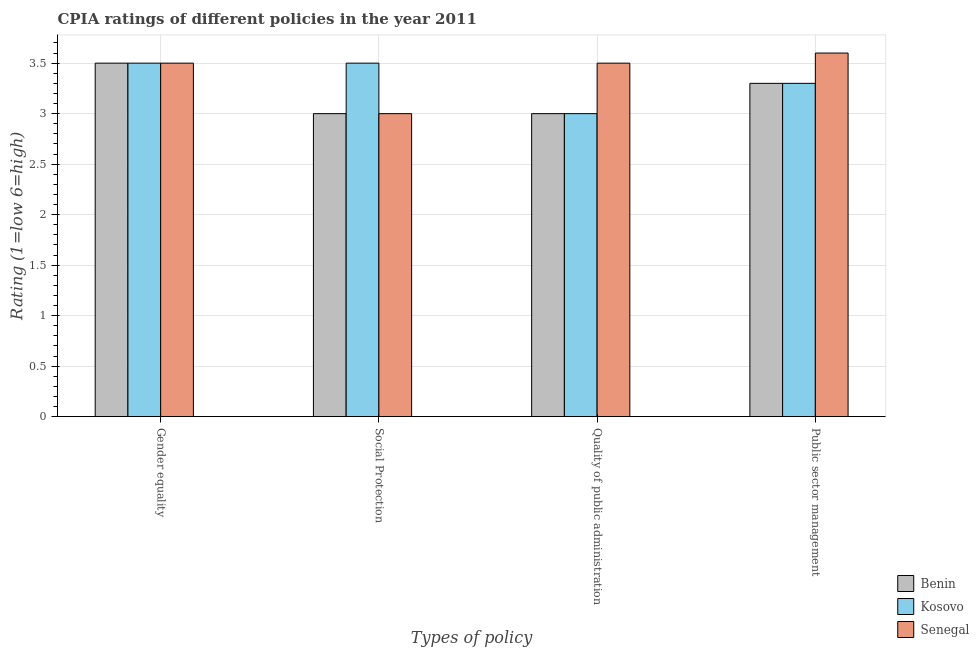Are the number of bars per tick equal to the number of legend labels?
Provide a short and direct response. Yes. How many bars are there on the 3rd tick from the left?
Provide a succinct answer. 3. What is the label of the 1st group of bars from the left?
Provide a short and direct response. Gender equality. In which country was the cpia rating of gender equality maximum?
Give a very brief answer. Benin. In which country was the cpia rating of quality of public administration minimum?
Offer a terse response. Benin. What is the difference between the cpia rating of public sector management in Senegal and that in Kosovo?
Provide a short and direct response. 0.3. What is the difference between the cpia rating of public sector management in Senegal and the cpia rating of social protection in Kosovo?
Keep it short and to the point. 0.1. What is the average cpia rating of public sector management per country?
Ensure brevity in your answer.  3.4. What is the difference between the cpia rating of public sector management and cpia rating of quality of public administration in Kosovo?
Provide a succinct answer. 0.3. Is the difference between the cpia rating of gender equality in Kosovo and Senegal greater than the difference between the cpia rating of social protection in Kosovo and Senegal?
Keep it short and to the point. No. What is the difference between the highest and the second highest cpia rating of quality of public administration?
Offer a very short reply. 0.5. What is the difference between the highest and the lowest cpia rating of public sector management?
Your answer should be compact. 0.3. Is it the case that in every country, the sum of the cpia rating of social protection and cpia rating of quality of public administration is greater than the sum of cpia rating of public sector management and cpia rating of gender equality?
Ensure brevity in your answer.  No. What does the 3rd bar from the left in Public sector management represents?
Provide a succinct answer. Senegal. What does the 2nd bar from the right in Public sector management represents?
Your response must be concise. Kosovo. Are all the bars in the graph horizontal?
Provide a succinct answer. No. How many countries are there in the graph?
Offer a very short reply. 3. What is the difference between two consecutive major ticks on the Y-axis?
Keep it short and to the point. 0.5. Does the graph contain any zero values?
Offer a terse response. No. Does the graph contain grids?
Your answer should be compact. Yes. Where does the legend appear in the graph?
Your response must be concise. Bottom right. How many legend labels are there?
Your response must be concise. 3. How are the legend labels stacked?
Make the answer very short. Vertical. What is the title of the graph?
Your answer should be very brief. CPIA ratings of different policies in the year 2011. What is the label or title of the X-axis?
Ensure brevity in your answer.  Types of policy. What is the Rating (1=low 6=high) of Senegal in Gender equality?
Offer a terse response. 3.5. What is the Rating (1=low 6=high) in Benin in Social Protection?
Keep it short and to the point. 3. What is the Rating (1=low 6=high) of Benin in Quality of public administration?
Offer a terse response. 3. What is the Rating (1=low 6=high) of Senegal in Quality of public administration?
Give a very brief answer. 3.5. What is the Rating (1=low 6=high) in Benin in Public sector management?
Your answer should be compact. 3.3. What is the Rating (1=low 6=high) of Kosovo in Public sector management?
Keep it short and to the point. 3.3. Across all Types of policy, what is the minimum Rating (1=low 6=high) in Kosovo?
Ensure brevity in your answer.  3. Across all Types of policy, what is the minimum Rating (1=low 6=high) in Senegal?
Keep it short and to the point. 3. What is the total Rating (1=low 6=high) of Benin in the graph?
Offer a very short reply. 12.8. What is the total Rating (1=low 6=high) of Kosovo in the graph?
Ensure brevity in your answer.  13.3. What is the total Rating (1=low 6=high) in Senegal in the graph?
Give a very brief answer. 13.6. What is the difference between the Rating (1=low 6=high) in Benin in Gender equality and that in Social Protection?
Provide a succinct answer. 0.5. What is the difference between the Rating (1=low 6=high) of Senegal in Gender equality and that in Social Protection?
Offer a terse response. 0.5. What is the difference between the Rating (1=low 6=high) of Benin in Gender equality and that in Quality of public administration?
Make the answer very short. 0.5. What is the difference between the Rating (1=low 6=high) of Kosovo in Gender equality and that in Quality of public administration?
Your answer should be very brief. 0.5. What is the difference between the Rating (1=low 6=high) in Benin in Gender equality and that in Public sector management?
Offer a terse response. 0.2. What is the difference between the Rating (1=low 6=high) in Kosovo in Gender equality and that in Public sector management?
Make the answer very short. 0.2. What is the difference between the Rating (1=low 6=high) of Senegal in Gender equality and that in Public sector management?
Ensure brevity in your answer.  -0.1. What is the difference between the Rating (1=low 6=high) in Benin in Social Protection and that in Public sector management?
Make the answer very short. -0.3. What is the difference between the Rating (1=low 6=high) of Senegal in Social Protection and that in Public sector management?
Offer a very short reply. -0.6. What is the difference between the Rating (1=low 6=high) of Benin in Quality of public administration and that in Public sector management?
Your answer should be compact. -0.3. What is the difference between the Rating (1=low 6=high) in Senegal in Quality of public administration and that in Public sector management?
Make the answer very short. -0.1. What is the difference between the Rating (1=low 6=high) of Kosovo in Gender equality and the Rating (1=low 6=high) of Senegal in Social Protection?
Your answer should be compact. 0.5. What is the difference between the Rating (1=low 6=high) in Benin in Gender equality and the Rating (1=low 6=high) in Kosovo in Quality of public administration?
Make the answer very short. 0.5. What is the difference between the Rating (1=low 6=high) in Benin in Gender equality and the Rating (1=low 6=high) in Kosovo in Public sector management?
Keep it short and to the point. 0.2. What is the difference between the Rating (1=low 6=high) in Benin in Social Protection and the Rating (1=low 6=high) in Kosovo in Quality of public administration?
Provide a succinct answer. 0. What is the difference between the Rating (1=low 6=high) in Kosovo in Social Protection and the Rating (1=low 6=high) in Senegal in Quality of public administration?
Provide a succinct answer. 0. What is the difference between the Rating (1=low 6=high) in Benin in Social Protection and the Rating (1=low 6=high) in Kosovo in Public sector management?
Ensure brevity in your answer.  -0.3. What is the difference between the Rating (1=low 6=high) of Benin in Quality of public administration and the Rating (1=low 6=high) of Kosovo in Public sector management?
Make the answer very short. -0.3. What is the difference between the Rating (1=low 6=high) of Kosovo in Quality of public administration and the Rating (1=low 6=high) of Senegal in Public sector management?
Provide a succinct answer. -0.6. What is the average Rating (1=low 6=high) of Kosovo per Types of policy?
Offer a very short reply. 3.33. What is the difference between the Rating (1=low 6=high) of Benin and Rating (1=low 6=high) of Senegal in Gender equality?
Provide a short and direct response. 0. What is the difference between the Rating (1=low 6=high) of Kosovo and Rating (1=low 6=high) of Senegal in Gender equality?
Your answer should be very brief. 0. What is the difference between the Rating (1=low 6=high) of Benin and Rating (1=low 6=high) of Kosovo in Social Protection?
Your response must be concise. -0.5. What is the difference between the Rating (1=low 6=high) in Benin and Rating (1=low 6=high) in Senegal in Social Protection?
Your answer should be very brief. 0. What is the difference between the Rating (1=low 6=high) of Kosovo and Rating (1=low 6=high) of Senegal in Quality of public administration?
Provide a short and direct response. -0.5. What is the ratio of the Rating (1=low 6=high) of Benin in Gender equality to that in Social Protection?
Your answer should be very brief. 1.17. What is the ratio of the Rating (1=low 6=high) in Kosovo in Gender equality to that in Social Protection?
Provide a short and direct response. 1. What is the ratio of the Rating (1=low 6=high) in Senegal in Gender equality to that in Social Protection?
Your answer should be compact. 1.17. What is the ratio of the Rating (1=low 6=high) in Benin in Gender equality to that in Quality of public administration?
Offer a very short reply. 1.17. What is the ratio of the Rating (1=low 6=high) of Benin in Gender equality to that in Public sector management?
Give a very brief answer. 1.06. What is the ratio of the Rating (1=low 6=high) of Kosovo in Gender equality to that in Public sector management?
Ensure brevity in your answer.  1.06. What is the ratio of the Rating (1=low 6=high) of Senegal in Gender equality to that in Public sector management?
Keep it short and to the point. 0.97. What is the ratio of the Rating (1=low 6=high) in Benin in Social Protection to that in Quality of public administration?
Your answer should be compact. 1. What is the ratio of the Rating (1=low 6=high) in Kosovo in Social Protection to that in Quality of public administration?
Keep it short and to the point. 1.17. What is the ratio of the Rating (1=low 6=high) of Benin in Social Protection to that in Public sector management?
Your response must be concise. 0.91. What is the ratio of the Rating (1=low 6=high) in Kosovo in Social Protection to that in Public sector management?
Provide a succinct answer. 1.06. What is the ratio of the Rating (1=low 6=high) of Benin in Quality of public administration to that in Public sector management?
Provide a short and direct response. 0.91. What is the ratio of the Rating (1=low 6=high) in Kosovo in Quality of public administration to that in Public sector management?
Provide a short and direct response. 0.91. What is the ratio of the Rating (1=low 6=high) in Senegal in Quality of public administration to that in Public sector management?
Give a very brief answer. 0.97. What is the difference between the highest and the second highest Rating (1=low 6=high) of Kosovo?
Ensure brevity in your answer.  0. What is the difference between the highest and the second highest Rating (1=low 6=high) of Senegal?
Your response must be concise. 0.1. What is the difference between the highest and the lowest Rating (1=low 6=high) of Senegal?
Offer a terse response. 0.6. 